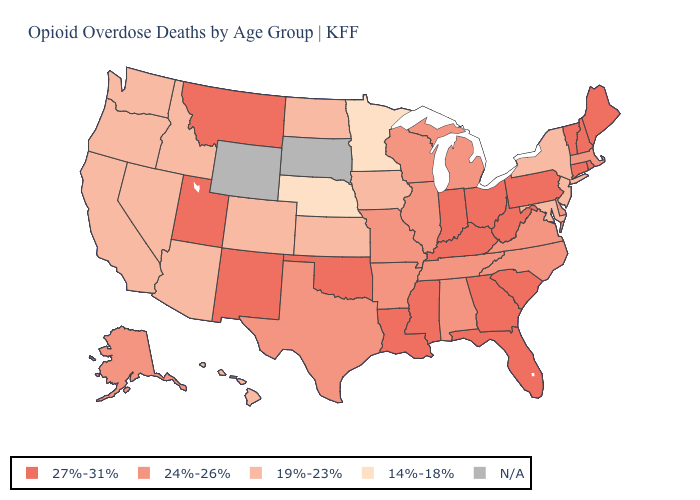Which states have the lowest value in the USA?
Answer briefly. Minnesota, Nebraska. What is the highest value in the USA?
Be succinct. 27%-31%. Which states hav the highest value in the West?
Answer briefly. Montana, New Mexico, Utah. Does Minnesota have the lowest value in the USA?
Write a very short answer. Yes. What is the highest value in the MidWest ?
Keep it brief. 27%-31%. Name the states that have a value in the range 27%-31%?
Be succinct. Connecticut, Florida, Georgia, Indiana, Kentucky, Louisiana, Maine, Mississippi, Montana, New Hampshire, New Mexico, Ohio, Oklahoma, Pennsylvania, Rhode Island, South Carolina, Utah, Vermont, West Virginia. Name the states that have a value in the range 27%-31%?
Be succinct. Connecticut, Florida, Georgia, Indiana, Kentucky, Louisiana, Maine, Mississippi, Montana, New Hampshire, New Mexico, Ohio, Oklahoma, Pennsylvania, Rhode Island, South Carolina, Utah, Vermont, West Virginia. Name the states that have a value in the range N/A?
Concise answer only. South Dakota, Wyoming. What is the highest value in states that border Mississippi?
Give a very brief answer. 27%-31%. Name the states that have a value in the range 27%-31%?
Keep it brief. Connecticut, Florida, Georgia, Indiana, Kentucky, Louisiana, Maine, Mississippi, Montana, New Hampshire, New Mexico, Ohio, Oklahoma, Pennsylvania, Rhode Island, South Carolina, Utah, Vermont, West Virginia. Does Minnesota have the lowest value in the MidWest?
Write a very short answer. Yes. What is the highest value in states that border Illinois?
Keep it brief. 27%-31%. Does West Virginia have the highest value in the USA?
Write a very short answer. Yes. What is the value of Nevada?
Answer briefly. 19%-23%. 